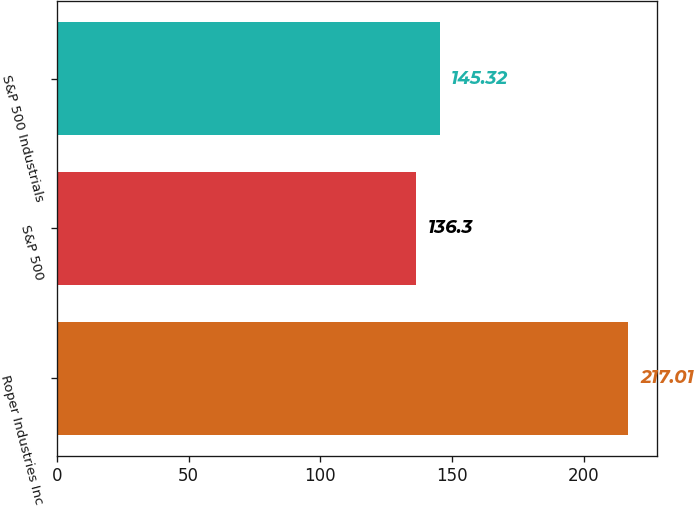<chart> <loc_0><loc_0><loc_500><loc_500><bar_chart><fcel>Roper Industries Inc<fcel>S&P 500<fcel>S&P 500 Industrials<nl><fcel>217.01<fcel>136.3<fcel>145.32<nl></chart> 